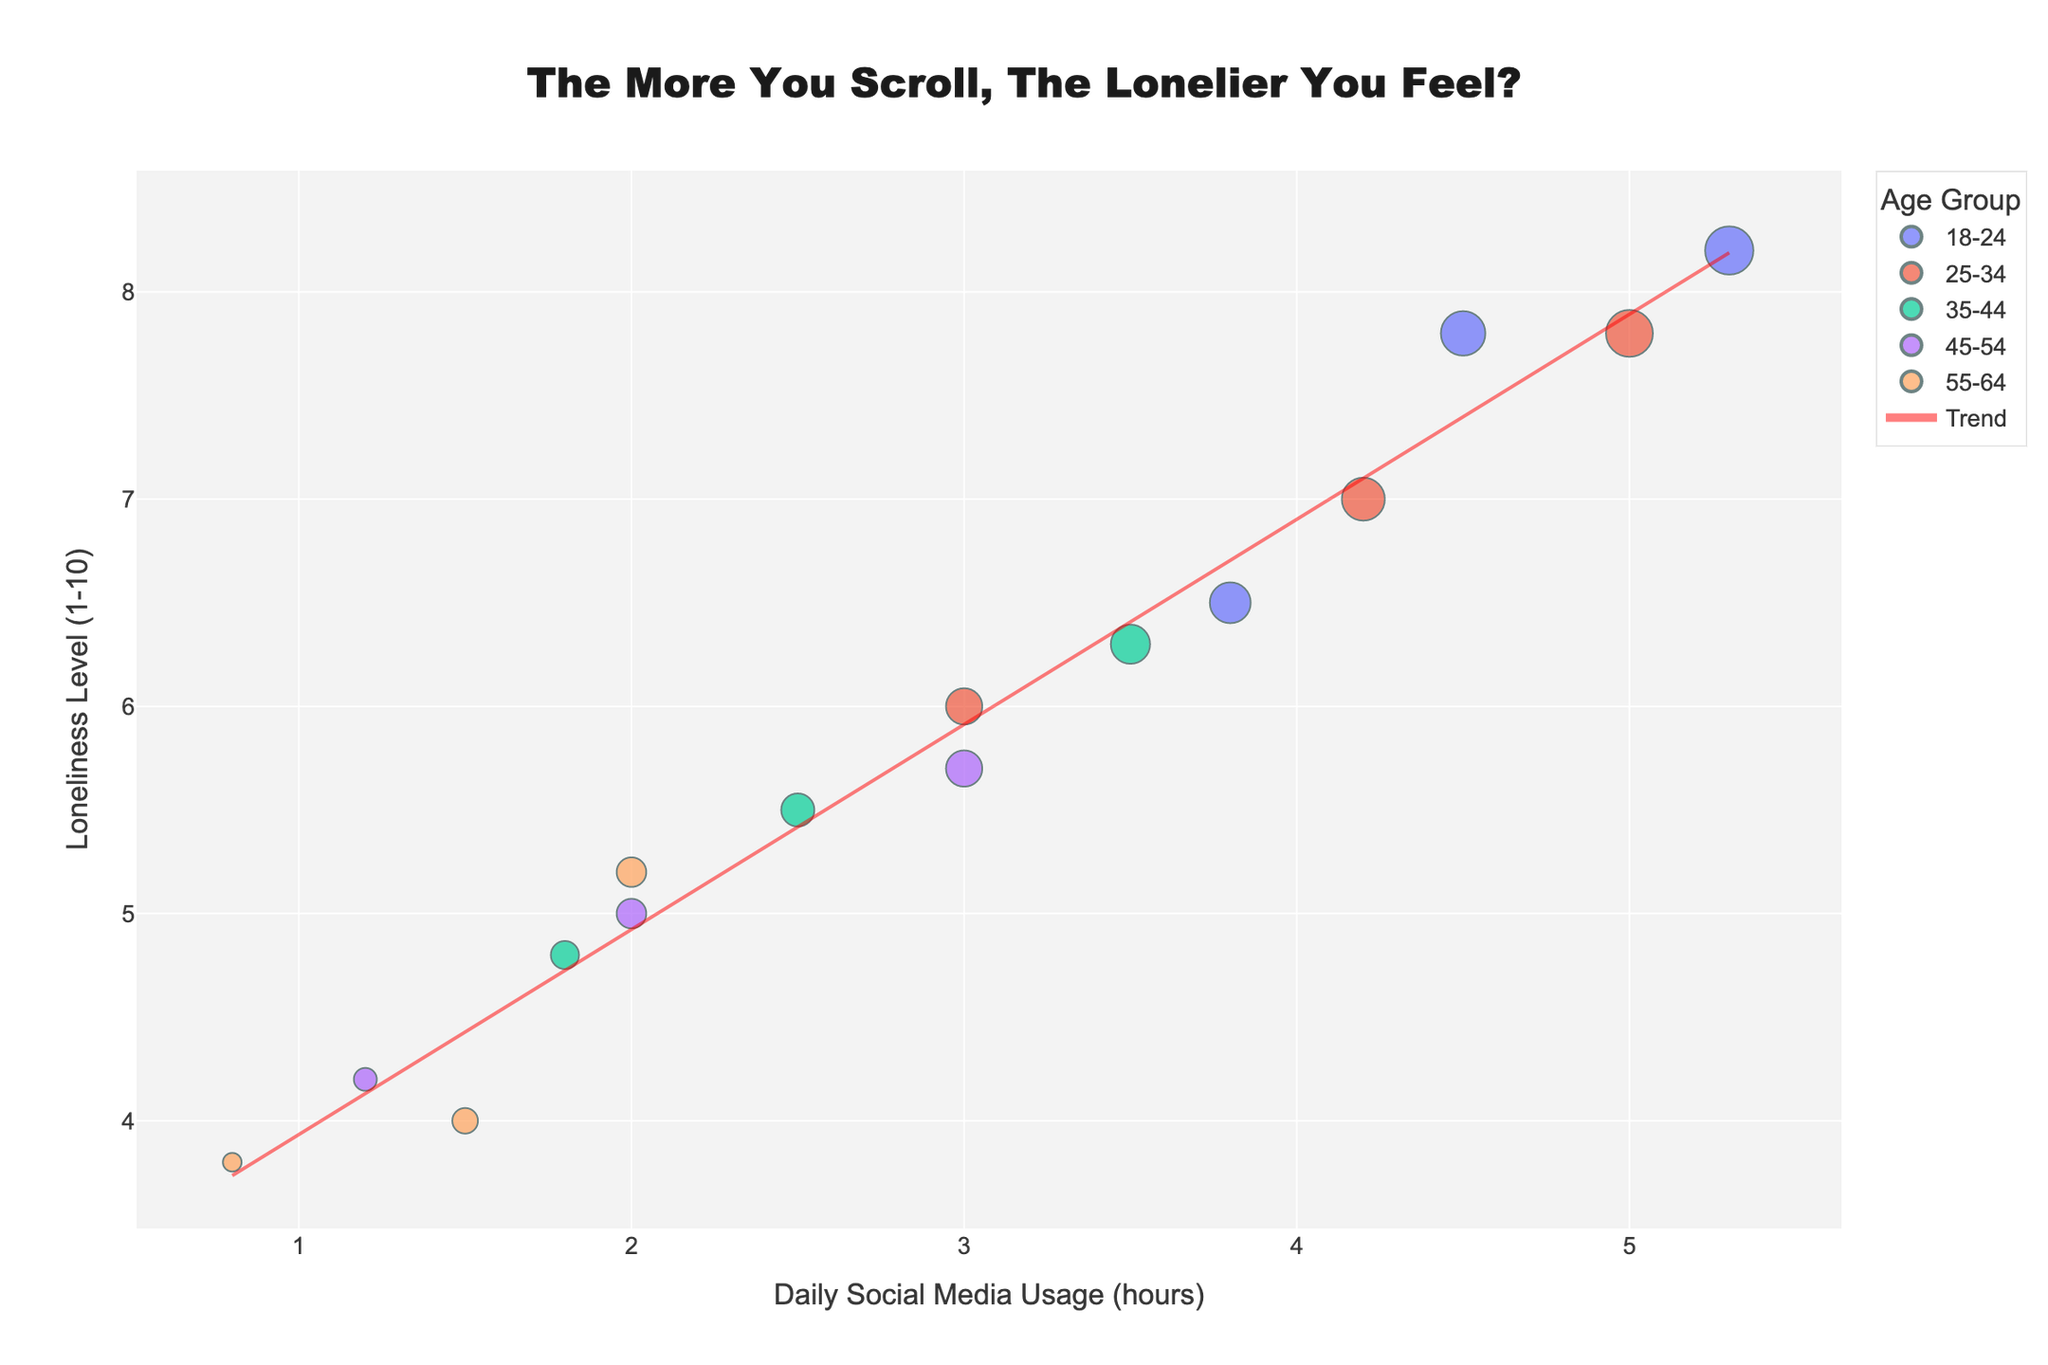What's the title of the plot? The title can be found at the top of the plot and reads: "The More You Scroll, The Lonelier You Feel?".
Answer: The More You Scroll, The Lonelier You Feel? What are the axes labels? The axes labels are present on the horizontal and vertical axes. The x-axis label is "Daily Social Media Usage (hours)", and the y-axis label is "Loneliness Level (1-10)".
Answer: Daily Social Media Usage (hours), Loneliness Level (1-10) Which age group has the highest average daily social media usage? By looking at the scatter plot, the age group with the highest average daily social media usage is the one with the largest clustered points to the right. This is the 18-24 age group.
Answer: 18-24 What is the trend line's slope? The slope of the trend line can be inferred from the positive inclination, indicating a positive relationship between daily social media usage and reported loneliness levels. The exact value is not shown but we know it's positive.
Answer: Positive How many age groups are represented in the scatter plot? The legend indicates all represented age groups. Five different age groups are listed in the legend, from "18-24" to "55-64".
Answer: 5 Comparing the 45-54 and 18-24 age groups, which one reports higher loneliness levels at 3 hours of daily social media usage? By comparing the points at around 3 hours on the x-axis, we see the 18-24 age group's loneliness levels range higher than those of the 45-54 age group.
Answer: 18-24 What is the average reported loneliness level for the age group 25-34? Add the reported loneliness levels for the 25-34 age group from the data points and divide by the number of points: (6.0 + 7.0 + 7.8) / 3 = 20.8 / 3 = 6.93.
Answer: 6.93 Does higher daily social media usage correspond to higher loneliness levels according to the trend line? The trend line shows a positive correlation, i.e., as the daily social media usage increases, the reported loneliness levels also tend to increase.
Answer: Yes Which age group has data points below a loneliness level of 5? By inspecting the plot, the only age group with all points below a loneliness level of 5 is the 55-64 age group.
Answer: 55-64 